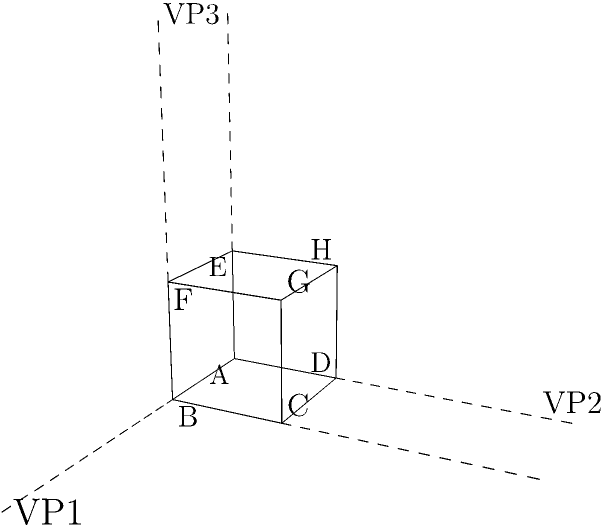In the given perspective drawing of a cube, how many vanishing points are visible, and what does this indicate about the type of perspective used in this representation? To answer this question, let's analyze the image step-by-step:

1. Observe the cube: The cube is drawn in a 3D perspective view, with its edges converging towards different points in space.

2. Identify the vanishing points:
   a. VP1: The horizontal lines on the x-axis converge to this point.
   b. VP2: The vertical lines on the y-axis converge to this point.
   c. VP3: The lines representing depth (z-axis) converge to this point.

3. Count the vanishing points: There are three distinct vanishing points visible in the image.

4. Determine the type of perspective:
   - One-point perspective: Uses one vanishing point
   - Two-point perspective: Uses two vanishing points
   - Three-point perspective: Uses three vanishing points

5. Conclusion: Since we have identified three vanishing points, this representation uses three-point perspective.

6. Significance of three-point perspective:
   - It provides a more realistic and dynamic view of the object.
   - It's often used when depicting objects from extreme angles, such as looking up at tall buildings or down from high vantage points.
   - In photography, this perspective can be achieved by tilting the camera, creating a more dramatic and immersive image.
Answer: Three vanishing points; three-point perspective 